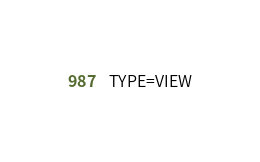Convert code to text. <code><loc_0><loc_0><loc_500><loc_500><_VisualBasic_>TYPE=VIEW</code> 